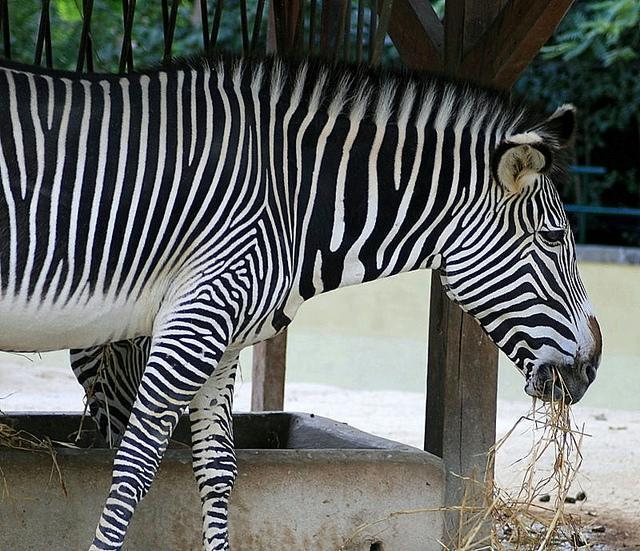How many zebras can you see?
Give a very brief answer. 2. How many giraffes are sitting there?
Give a very brief answer. 0. 